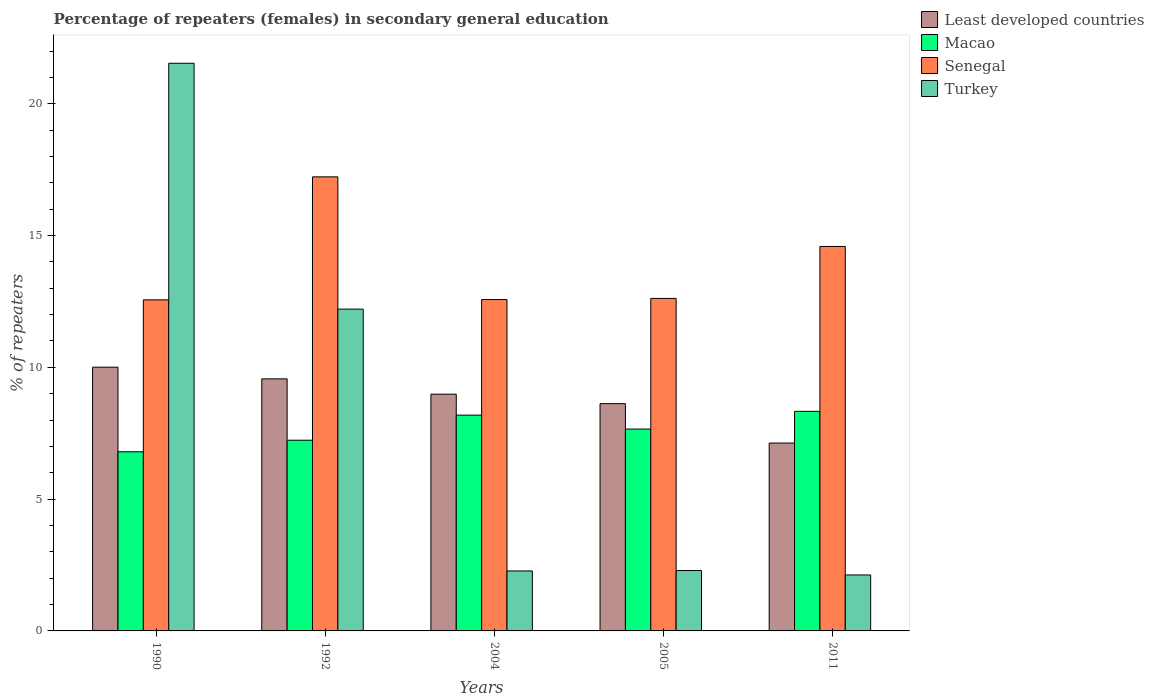How many different coloured bars are there?
Provide a succinct answer. 4. Are the number of bars per tick equal to the number of legend labels?
Keep it short and to the point. Yes. Are the number of bars on each tick of the X-axis equal?
Offer a very short reply. Yes. How many bars are there on the 1st tick from the right?
Offer a very short reply. 4. What is the label of the 4th group of bars from the left?
Provide a succinct answer. 2005. What is the percentage of female repeaters in Least developed countries in 2004?
Your response must be concise. 8.98. Across all years, what is the maximum percentage of female repeaters in Senegal?
Make the answer very short. 17.23. Across all years, what is the minimum percentage of female repeaters in Least developed countries?
Offer a terse response. 7.13. What is the total percentage of female repeaters in Senegal in the graph?
Your answer should be compact. 69.56. What is the difference between the percentage of female repeaters in Turkey in 2005 and that in 2011?
Provide a short and direct response. 0.17. What is the difference between the percentage of female repeaters in Senegal in 2011 and the percentage of female repeaters in Least developed countries in 2004?
Ensure brevity in your answer.  5.6. What is the average percentage of female repeaters in Turkey per year?
Provide a short and direct response. 8.09. In the year 1990, what is the difference between the percentage of female repeaters in Senegal and percentage of female repeaters in Turkey?
Offer a very short reply. -8.98. What is the ratio of the percentage of female repeaters in Least developed countries in 2004 to that in 2011?
Offer a terse response. 1.26. What is the difference between the highest and the second highest percentage of female repeaters in Macao?
Provide a succinct answer. 0.14. What is the difference between the highest and the lowest percentage of female repeaters in Least developed countries?
Make the answer very short. 2.88. Is it the case that in every year, the sum of the percentage of female repeaters in Macao and percentage of female repeaters in Senegal is greater than the sum of percentage of female repeaters in Least developed countries and percentage of female repeaters in Turkey?
Offer a terse response. Yes. What does the 2nd bar from the left in 2004 represents?
Give a very brief answer. Macao. What does the 3rd bar from the right in 2004 represents?
Offer a terse response. Macao. How many bars are there?
Offer a terse response. 20. Are all the bars in the graph horizontal?
Provide a short and direct response. No. How many years are there in the graph?
Your answer should be very brief. 5. Are the values on the major ticks of Y-axis written in scientific E-notation?
Your response must be concise. No. Does the graph contain any zero values?
Provide a short and direct response. No. How many legend labels are there?
Provide a short and direct response. 4. How are the legend labels stacked?
Your response must be concise. Vertical. What is the title of the graph?
Your response must be concise. Percentage of repeaters (females) in secondary general education. What is the label or title of the X-axis?
Provide a short and direct response. Years. What is the label or title of the Y-axis?
Offer a terse response. % of repeaters. What is the % of repeaters in Least developed countries in 1990?
Provide a succinct answer. 10.01. What is the % of repeaters of Macao in 1990?
Ensure brevity in your answer.  6.8. What is the % of repeaters in Senegal in 1990?
Make the answer very short. 12.56. What is the % of repeaters in Turkey in 1990?
Provide a short and direct response. 21.54. What is the % of repeaters in Least developed countries in 1992?
Offer a very short reply. 9.56. What is the % of repeaters in Macao in 1992?
Make the answer very short. 7.23. What is the % of repeaters in Senegal in 1992?
Your answer should be compact. 17.23. What is the % of repeaters of Turkey in 1992?
Offer a very short reply. 12.21. What is the % of repeaters of Least developed countries in 2004?
Offer a very short reply. 8.98. What is the % of repeaters in Macao in 2004?
Provide a short and direct response. 8.19. What is the % of repeaters in Senegal in 2004?
Give a very brief answer. 12.57. What is the % of repeaters of Turkey in 2004?
Make the answer very short. 2.28. What is the % of repeaters of Least developed countries in 2005?
Your answer should be very brief. 8.62. What is the % of repeaters in Macao in 2005?
Your answer should be compact. 7.66. What is the % of repeaters of Senegal in 2005?
Provide a succinct answer. 12.61. What is the % of repeaters in Turkey in 2005?
Ensure brevity in your answer.  2.29. What is the % of repeaters of Least developed countries in 2011?
Keep it short and to the point. 7.13. What is the % of repeaters of Macao in 2011?
Ensure brevity in your answer.  8.33. What is the % of repeaters of Senegal in 2011?
Your response must be concise. 14.59. What is the % of repeaters of Turkey in 2011?
Provide a succinct answer. 2.12. Across all years, what is the maximum % of repeaters of Least developed countries?
Give a very brief answer. 10.01. Across all years, what is the maximum % of repeaters of Macao?
Make the answer very short. 8.33. Across all years, what is the maximum % of repeaters of Senegal?
Your answer should be very brief. 17.23. Across all years, what is the maximum % of repeaters of Turkey?
Make the answer very short. 21.54. Across all years, what is the minimum % of repeaters in Least developed countries?
Make the answer very short. 7.13. Across all years, what is the minimum % of repeaters of Macao?
Provide a short and direct response. 6.8. Across all years, what is the minimum % of repeaters of Senegal?
Keep it short and to the point. 12.56. Across all years, what is the minimum % of repeaters of Turkey?
Make the answer very short. 2.12. What is the total % of repeaters of Least developed countries in the graph?
Make the answer very short. 44.3. What is the total % of repeaters of Macao in the graph?
Keep it short and to the point. 38.21. What is the total % of repeaters of Senegal in the graph?
Keep it short and to the point. 69.56. What is the total % of repeaters in Turkey in the graph?
Make the answer very short. 40.44. What is the difference between the % of repeaters of Least developed countries in 1990 and that in 1992?
Keep it short and to the point. 0.44. What is the difference between the % of repeaters of Macao in 1990 and that in 1992?
Your answer should be very brief. -0.44. What is the difference between the % of repeaters of Senegal in 1990 and that in 1992?
Keep it short and to the point. -4.67. What is the difference between the % of repeaters of Turkey in 1990 and that in 1992?
Your answer should be very brief. 9.33. What is the difference between the % of repeaters in Least developed countries in 1990 and that in 2004?
Make the answer very short. 1.02. What is the difference between the % of repeaters of Macao in 1990 and that in 2004?
Your response must be concise. -1.39. What is the difference between the % of repeaters in Senegal in 1990 and that in 2004?
Offer a very short reply. -0.01. What is the difference between the % of repeaters of Turkey in 1990 and that in 2004?
Offer a very short reply. 19.26. What is the difference between the % of repeaters in Least developed countries in 1990 and that in 2005?
Your answer should be compact. 1.38. What is the difference between the % of repeaters in Macao in 1990 and that in 2005?
Keep it short and to the point. -0.86. What is the difference between the % of repeaters of Senegal in 1990 and that in 2005?
Your answer should be very brief. -0.05. What is the difference between the % of repeaters of Turkey in 1990 and that in 2005?
Your response must be concise. 19.24. What is the difference between the % of repeaters of Least developed countries in 1990 and that in 2011?
Provide a succinct answer. 2.88. What is the difference between the % of repeaters of Macao in 1990 and that in 2011?
Offer a very short reply. -1.53. What is the difference between the % of repeaters in Senegal in 1990 and that in 2011?
Give a very brief answer. -2.03. What is the difference between the % of repeaters in Turkey in 1990 and that in 2011?
Offer a terse response. 19.41. What is the difference between the % of repeaters of Least developed countries in 1992 and that in 2004?
Your response must be concise. 0.58. What is the difference between the % of repeaters of Macao in 1992 and that in 2004?
Give a very brief answer. -0.95. What is the difference between the % of repeaters in Senegal in 1992 and that in 2004?
Your response must be concise. 4.66. What is the difference between the % of repeaters of Turkey in 1992 and that in 2004?
Offer a terse response. 9.93. What is the difference between the % of repeaters in Least developed countries in 1992 and that in 2005?
Ensure brevity in your answer.  0.94. What is the difference between the % of repeaters in Macao in 1992 and that in 2005?
Give a very brief answer. -0.42. What is the difference between the % of repeaters of Senegal in 1992 and that in 2005?
Give a very brief answer. 4.61. What is the difference between the % of repeaters in Turkey in 1992 and that in 2005?
Provide a succinct answer. 9.92. What is the difference between the % of repeaters in Least developed countries in 1992 and that in 2011?
Make the answer very short. 2.43. What is the difference between the % of repeaters in Macao in 1992 and that in 2011?
Make the answer very short. -1.1. What is the difference between the % of repeaters in Senegal in 1992 and that in 2011?
Offer a terse response. 2.64. What is the difference between the % of repeaters in Turkey in 1992 and that in 2011?
Provide a short and direct response. 10.09. What is the difference between the % of repeaters in Least developed countries in 2004 and that in 2005?
Give a very brief answer. 0.36. What is the difference between the % of repeaters in Macao in 2004 and that in 2005?
Provide a short and direct response. 0.53. What is the difference between the % of repeaters in Senegal in 2004 and that in 2005?
Make the answer very short. -0.04. What is the difference between the % of repeaters of Turkey in 2004 and that in 2005?
Make the answer very short. -0.02. What is the difference between the % of repeaters of Least developed countries in 2004 and that in 2011?
Your answer should be very brief. 1.85. What is the difference between the % of repeaters in Macao in 2004 and that in 2011?
Ensure brevity in your answer.  -0.14. What is the difference between the % of repeaters of Senegal in 2004 and that in 2011?
Provide a succinct answer. -2.02. What is the difference between the % of repeaters in Turkey in 2004 and that in 2011?
Give a very brief answer. 0.15. What is the difference between the % of repeaters in Least developed countries in 2005 and that in 2011?
Your answer should be very brief. 1.49. What is the difference between the % of repeaters in Macao in 2005 and that in 2011?
Provide a short and direct response. -0.67. What is the difference between the % of repeaters of Senegal in 2005 and that in 2011?
Your answer should be compact. -1.97. What is the difference between the % of repeaters in Turkey in 2005 and that in 2011?
Offer a very short reply. 0.17. What is the difference between the % of repeaters of Least developed countries in 1990 and the % of repeaters of Macao in 1992?
Your answer should be compact. 2.77. What is the difference between the % of repeaters of Least developed countries in 1990 and the % of repeaters of Senegal in 1992?
Make the answer very short. -7.22. What is the difference between the % of repeaters in Least developed countries in 1990 and the % of repeaters in Turkey in 1992?
Offer a very short reply. -2.2. What is the difference between the % of repeaters in Macao in 1990 and the % of repeaters in Senegal in 1992?
Your answer should be compact. -10.43. What is the difference between the % of repeaters in Macao in 1990 and the % of repeaters in Turkey in 1992?
Offer a very short reply. -5.41. What is the difference between the % of repeaters in Senegal in 1990 and the % of repeaters in Turkey in 1992?
Provide a succinct answer. 0.35. What is the difference between the % of repeaters of Least developed countries in 1990 and the % of repeaters of Macao in 2004?
Your answer should be very brief. 1.82. What is the difference between the % of repeaters of Least developed countries in 1990 and the % of repeaters of Senegal in 2004?
Ensure brevity in your answer.  -2.57. What is the difference between the % of repeaters of Least developed countries in 1990 and the % of repeaters of Turkey in 2004?
Provide a short and direct response. 7.73. What is the difference between the % of repeaters of Macao in 1990 and the % of repeaters of Senegal in 2004?
Ensure brevity in your answer.  -5.77. What is the difference between the % of repeaters of Macao in 1990 and the % of repeaters of Turkey in 2004?
Your response must be concise. 4.52. What is the difference between the % of repeaters in Senegal in 1990 and the % of repeaters in Turkey in 2004?
Offer a very short reply. 10.28. What is the difference between the % of repeaters in Least developed countries in 1990 and the % of repeaters in Macao in 2005?
Your answer should be compact. 2.35. What is the difference between the % of repeaters of Least developed countries in 1990 and the % of repeaters of Senegal in 2005?
Your response must be concise. -2.61. What is the difference between the % of repeaters of Least developed countries in 1990 and the % of repeaters of Turkey in 2005?
Your answer should be very brief. 7.71. What is the difference between the % of repeaters in Macao in 1990 and the % of repeaters in Senegal in 2005?
Offer a very short reply. -5.82. What is the difference between the % of repeaters in Macao in 1990 and the % of repeaters in Turkey in 2005?
Offer a terse response. 4.5. What is the difference between the % of repeaters in Senegal in 1990 and the % of repeaters in Turkey in 2005?
Provide a short and direct response. 10.27. What is the difference between the % of repeaters in Least developed countries in 1990 and the % of repeaters in Macao in 2011?
Make the answer very short. 1.68. What is the difference between the % of repeaters of Least developed countries in 1990 and the % of repeaters of Senegal in 2011?
Ensure brevity in your answer.  -4.58. What is the difference between the % of repeaters of Least developed countries in 1990 and the % of repeaters of Turkey in 2011?
Your answer should be compact. 7.88. What is the difference between the % of repeaters of Macao in 1990 and the % of repeaters of Senegal in 2011?
Offer a terse response. -7.79. What is the difference between the % of repeaters of Macao in 1990 and the % of repeaters of Turkey in 2011?
Offer a terse response. 4.67. What is the difference between the % of repeaters in Senegal in 1990 and the % of repeaters in Turkey in 2011?
Keep it short and to the point. 10.44. What is the difference between the % of repeaters in Least developed countries in 1992 and the % of repeaters in Macao in 2004?
Give a very brief answer. 1.38. What is the difference between the % of repeaters in Least developed countries in 1992 and the % of repeaters in Senegal in 2004?
Offer a very short reply. -3.01. What is the difference between the % of repeaters in Least developed countries in 1992 and the % of repeaters in Turkey in 2004?
Provide a short and direct response. 7.29. What is the difference between the % of repeaters in Macao in 1992 and the % of repeaters in Senegal in 2004?
Provide a succinct answer. -5.34. What is the difference between the % of repeaters in Macao in 1992 and the % of repeaters in Turkey in 2004?
Make the answer very short. 4.96. What is the difference between the % of repeaters of Senegal in 1992 and the % of repeaters of Turkey in 2004?
Ensure brevity in your answer.  14.95. What is the difference between the % of repeaters in Least developed countries in 1992 and the % of repeaters in Macao in 2005?
Give a very brief answer. 1.9. What is the difference between the % of repeaters of Least developed countries in 1992 and the % of repeaters of Senegal in 2005?
Provide a short and direct response. -3.05. What is the difference between the % of repeaters in Least developed countries in 1992 and the % of repeaters in Turkey in 2005?
Ensure brevity in your answer.  7.27. What is the difference between the % of repeaters of Macao in 1992 and the % of repeaters of Senegal in 2005?
Provide a succinct answer. -5.38. What is the difference between the % of repeaters in Macao in 1992 and the % of repeaters in Turkey in 2005?
Your response must be concise. 4.94. What is the difference between the % of repeaters of Senegal in 1992 and the % of repeaters of Turkey in 2005?
Your answer should be compact. 14.94. What is the difference between the % of repeaters of Least developed countries in 1992 and the % of repeaters of Macao in 2011?
Your answer should be very brief. 1.23. What is the difference between the % of repeaters in Least developed countries in 1992 and the % of repeaters in Senegal in 2011?
Your answer should be very brief. -5.02. What is the difference between the % of repeaters in Least developed countries in 1992 and the % of repeaters in Turkey in 2011?
Keep it short and to the point. 7.44. What is the difference between the % of repeaters of Macao in 1992 and the % of repeaters of Senegal in 2011?
Keep it short and to the point. -7.35. What is the difference between the % of repeaters in Macao in 1992 and the % of repeaters in Turkey in 2011?
Make the answer very short. 5.11. What is the difference between the % of repeaters in Senegal in 1992 and the % of repeaters in Turkey in 2011?
Ensure brevity in your answer.  15.1. What is the difference between the % of repeaters of Least developed countries in 2004 and the % of repeaters of Macao in 2005?
Give a very brief answer. 1.32. What is the difference between the % of repeaters of Least developed countries in 2004 and the % of repeaters of Senegal in 2005?
Offer a terse response. -3.63. What is the difference between the % of repeaters of Least developed countries in 2004 and the % of repeaters of Turkey in 2005?
Your answer should be compact. 6.69. What is the difference between the % of repeaters in Macao in 2004 and the % of repeaters in Senegal in 2005?
Offer a very short reply. -4.43. What is the difference between the % of repeaters in Macao in 2004 and the % of repeaters in Turkey in 2005?
Keep it short and to the point. 5.89. What is the difference between the % of repeaters in Senegal in 2004 and the % of repeaters in Turkey in 2005?
Offer a terse response. 10.28. What is the difference between the % of repeaters in Least developed countries in 2004 and the % of repeaters in Macao in 2011?
Ensure brevity in your answer.  0.65. What is the difference between the % of repeaters in Least developed countries in 2004 and the % of repeaters in Senegal in 2011?
Offer a very short reply. -5.6. What is the difference between the % of repeaters in Least developed countries in 2004 and the % of repeaters in Turkey in 2011?
Your answer should be very brief. 6.86. What is the difference between the % of repeaters of Macao in 2004 and the % of repeaters of Senegal in 2011?
Your answer should be compact. -6.4. What is the difference between the % of repeaters of Macao in 2004 and the % of repeaters of Turkey in 2011?
Your answer should be very brief. 6.06. What is the difference between the % of repeaters in Senegal in 2004 and the % of repeaters in Turkey in 2011?
Your answer should be compact. 10.45. What is the difference between the % of repeaters of Least developed countries in 2005 and the % of repeaters of Macao in 2011?
Offer a very short reply. 0.29. What is the difference between the % of repeaters in Least developed countries in 2005 and the % of repeaters in Senegal in 2011?
Ensure brevity in your answer.  -5.96. What is the difference between the % of repeaters of Least developed countries in 2005 and the % of repeaters of Turkey in 2011?
Make the answer very short. 6.5. What is the difference between the % of repeaters in Macao in 2005 and the % of repeaters in Senegal in 2011?
Your response must be concise. -6.93. What is the difference between the % of repeaters of Macao in 2005 and the % of repeaters of Turkey in 2011?
Offer a very short reply. 5.54. What is the difference between the % of repeaters of Senegal in 2005 and the % of repeaters of Turkey in 2011?
Provide a succinct answer. 10.49. What is the average % of repeaters in Least developed countries per year?
Give a very brief answer. 8.86. What is the average % of repeaters in Macao per year?
Offer a terse response. 7.64. What is the average % of repeaters in Senegal per year?
Ensure brevity in your answer.  13.91. What is the average % of repeaters of Turkey per year?
Your answer should be compact. 8.09. In the year 1990, what is the difference between the % of repeaters of Least developed countries and % of repeaters of Macao?
Make the answer very short. 3.21. In the year 1990, what is the difference between the % of repeaters of Least developed countries and % of repeaters of Senegal?
Provide a succinct answer. -2.55. In the year 1990, what is the difference between the % of repeaters in Least developed countries and % of repeaters in Turkey?
Offer a very short reply. -11.53. In the year 1990, what is the difference between the % of repeaters of Macao and % of repeaters of Senegal?
Your answer should be compact. -5.76. In the year 1990, what is the difference between the % of repeaters in Macao and % of repeaters in Turkey?
Make the answer very short. -14.74. In the year 1990, what is the difference between the % of repeaters in Senegal and % of repeaters in Turkey?
Your answer should be compact. -8.98. In the year 1992, what is the difference between the % of repeaters of Least developed countries and % of repeaters of Macao?
Make the answer very short. 2.33. In the year 1992, what is the difference between the % of repeaters in Least developed countries and % of repeaters in Senegal?
Make the answer very short. -7.66. In the year 1992, what is the difference between the % of repeaters in Least developed countries and % of repeaters in Turkey?
Provide a succinct answer. -2.65. In the year 1992, what is the difference between the % of repeaters of Macao and % of repeaters of Senegal?
Give a very brief answer. -9.99. In the year 1992, what is the difference between the % of repeaters in Macao and % of repeaters in Turkey?
Make the answer very short. -4.97. In the year 1992, what is the difference between the % of repeaters of Senegal and % of repeaters of Turkey?
Your answer should be compact. 5.02. In the year 2004, what is the difference between the % of repeaters in Least developed countries and % of repeaters in Macao?
Offer a very short reply. 0.8. In the year 2004, what is the difference between the % of repeaters in Least developed countries and % of repeaters in Senegal?
Ensure brevity in your answer.  -3.59. In the year 2004, what is the difference between the % of repeaters in Least developed countries and % of repeaters in Turkey?
Make the answer very short. 6.71. In the year 2004, what is the difference between the % of repeaters in Macao and % of repeaters in Senegal?
Offer a very short reply. -4.38. In the year 2004, what is the difference between the % of repeaters in Macao and % of repeaters in Turkey?
Offer a terse response. 5.91. In the year 2004, what is the difference between the % of repeaters in Senegal and % of repeaters in Turkey?
Your response must be concise. 10.3. In the year 2005, what is the difference between the % of repeaters in Least developed countries and % of repeaters in Senegal?
Your response must be concise. -3.99. In the year 2005, what is the difference between the % of repeaters in Least developed countries and % of repeaters in Turkey?
Keep it short and to the point. 6.33. In the year 2005, what is the difference between the % of repeaters of Macao and % of repeaters of Senegal?
Ensure brevity in your answer.  -4.96. In the year 2005, what is the difference between the % of repeaters of Macao and % of repeaters of Turkey?
Make the answer very short. 5.37. In the year 2005, what is the difference between the % of repeaters in Senegal and % of repeaters in Turkey?
Your answer should be compact. 10.32. In the year 2011, what is the difference between the % of repeaters in Least developed countries and % of repeaters in Macao?
Offer a very short reply. -1.2. In the year 2011, what is the difference between the % of repeaters of Least developed countries and % of repeaters of Senegal?
Give a very brief answer. -7.46. In the year 2011, what is the difference between the % of repeaters of Least developed countries and % of repeaters of Turkey?
Your answer should be very brief. 5.01. In the year 2011, what is the difference between the % of repeaters in Macao and % of repeaters in Senegal?
Give a very brief answer. -6.26. In the year 2011, what is the difference between the % of repeaters of Macao and % of repeaters of Turkey?
Offer a very short reply. 6.21. In the year 2011, what is the difference between the % of repeaters of Senegal and % of repeaters of Turkey?
Keep it short and to the point. 12.46. What is the ratio of the % of repeaters in Least developed countries in 1990 to that in 1992?
Your response must be concise. 1.05. What is the ratio of the % of repeaters of Macao in 1990 to that in 1992?
Keep it short and to the point. 0.94. What is the ratio of the % of repeaters in Senegal in 1990 to that in 1992?
Your answer should be very brief. 0.73. What is the ratio of the % of repeaters of Turkey in 1990 to that in 1992?
Keep it short and to the point. 1.76. What is the ratio of the % of repeaters of Least developed countries in 1990 to that in 2004?
Provide a short and direct response. 1.11. What is the ratio of the % of repeaters in Macao in 1990 to that in 2004?
Your answer should be compact. 0.83. What is the ratio of the % of repeaters of Turkey in 1990 to that in 2004?
Your response must be concise. 9.46. What is the ratio of the % of repeaters of Least developed countries in 1990 to that in 2005?
Offer a terse response. 1.16. What is the ratio of the % of repeaters of Macao in 1990 to that in 2005?
Offer a terse response. 0.89. What is the ratio of the % of repeaters in Senegal in 1990 to that in 2005?
Keep it short and to the point. 1. What is the ratio of the % of repeaters of Turkey in 1990 to that in 2005?
Ensure brevity in your answer.  9.4. What is the ratio of the % of repeaters of Least developed countries in 1990 to that in 2011?
Ensure brevity in your answer.  1.4. What is the ratio of the % of repeaters in Macao in 1990 to that in 2011?
Ensure brevity in your answer.  0.82. What is the ratio of the % of repeaters in Senegal in 1990 to that in 2011?
Give a very brief answer. 0.86. What is the ratio of the % of repeaters of Turkey in 1990 to that in 2011?
Give a very brief answer. 10.14. What is the ratio of the % of repeaters of Least developed countries in 1992 to that in 2004?
Provide a short and direct response. 1.06. What is the ratio of the % of repeaters in Macao in 1992 to that in 2004?
Your answer should be very brief. 0.88. What is the ratio of the % of repeaters in Senegal in 1992 to that in 2004?
Offer a terse response. 1.37. What is the ratio of the % of repeaters in Turkey in 1992 to that in 2004?
Your answer should be very brief. 5.37. What is the ratio of the % of repeaters of Least developed countries in 1992 to that in 2005?
Offer a very short reply. 1.11. What is the ratio of the % of repeaters in Macao in 1992 to that in 2005?
Your answer should be compact. 0.94. What is the ratio of the % of repeaters in Senegal in 1992 to that in 2005?
Offer a terse response. 1.37. What is the ratio of the % of repeaters of Turkey in 1992 to that in 2005?
Keep it short and to the point. 5.33. What is the ratio of the % of repeaters in Least developed countries in 1992 to that in 2011?
Give a very brief answer. 1.34. What is the ratio of the % of repeaters in Macao in 1992 to that in 2011?
Keep it short and to the point. 0.87. What is the ratio of the % of repeaters of Senegal in 1992 to that in 2011?
Ensure brevity in your answer.  1.18. What is the ratio of the % of repeaters in Turkey in 1992 to that in 2011?
Ensure brevity in your answer.  5.75. What is the ratio of the % of repeaters in Least developed countries in 2004 to that in 2005?
Keep it short and to the point. 1.04. What is the ratio of the % of repeaters of Macao in 2004 to that in 2005?
Ensure brevity in your answer.  1.07. What is the ratio of the % of repeaters of Senegal in 2004 to that in 2005?
Provide a short and direct response. 1. What is the ratio of the % of repeaters of Turkey in 2004 to that in 2005?
Ensure brevity in your answer.  0.99. What is the ratio of the % of repeaters of Least developed countries in 2004 to that in 2011?
Ensure brevity in your answer.  1.26. What is the ratio of the % of repeaters in Macao in 2004 to that in 2011?
Give a very brief answer. 0.98. What is the ratio of the % of repeaters in Senegal in 2004 to that in 2011?
Give a very brief answer. 0.86. What is the ratio of the % of repeaters in Turkey in 2004 to that in 2011?
Keep it short and to the point. 1.07. What is the ratio of the % of repeaters of Least developed countries in 2005 to that in 2011?
Make the answer very short. 1.21. What is the ratio of the % of repeaters of Macao in 2005 to that in 2011?
Your answer should be very brief. 0.92. What is the ratio of the % of repeaters of Senegal in 2005 to that in 2011?
Keep it short and to the point. 0.86. What is the ratio of the % of repeaters of Turkey in 2005 to that in 2011?
Give a very brief answer. 1.08. What is the difference between the highest and the second highest % of repeaters in Least developed countries?
Provide a short and direct response. 0.44. What is the difference between the highest and the second highest % of repeaters of Macao?
Offer a terse response. 0.14. What is the difference between the highest and the second highest % of repeaters in Senegal?
Offer a terse response. 2.64. What is the difference between the highest and the second highest % of repeaters in Turkey?
Your answer should be very brief. 9.33. What is the difference between the highest and the lowest % of repeaters in Least developed countries?
Your response must be concise. 2.88. What is the difference between the highest and the lowest % of repeaters in Macao?
Your response must be concise. 1.53. What is the difference between the highest and the lowest % of repeaters in Senegal?
Your answer should be compact. 4.67. What is the difference between the highest and the lowest % of repeaters of Turkey?
Offer a terse response. 19.41. 